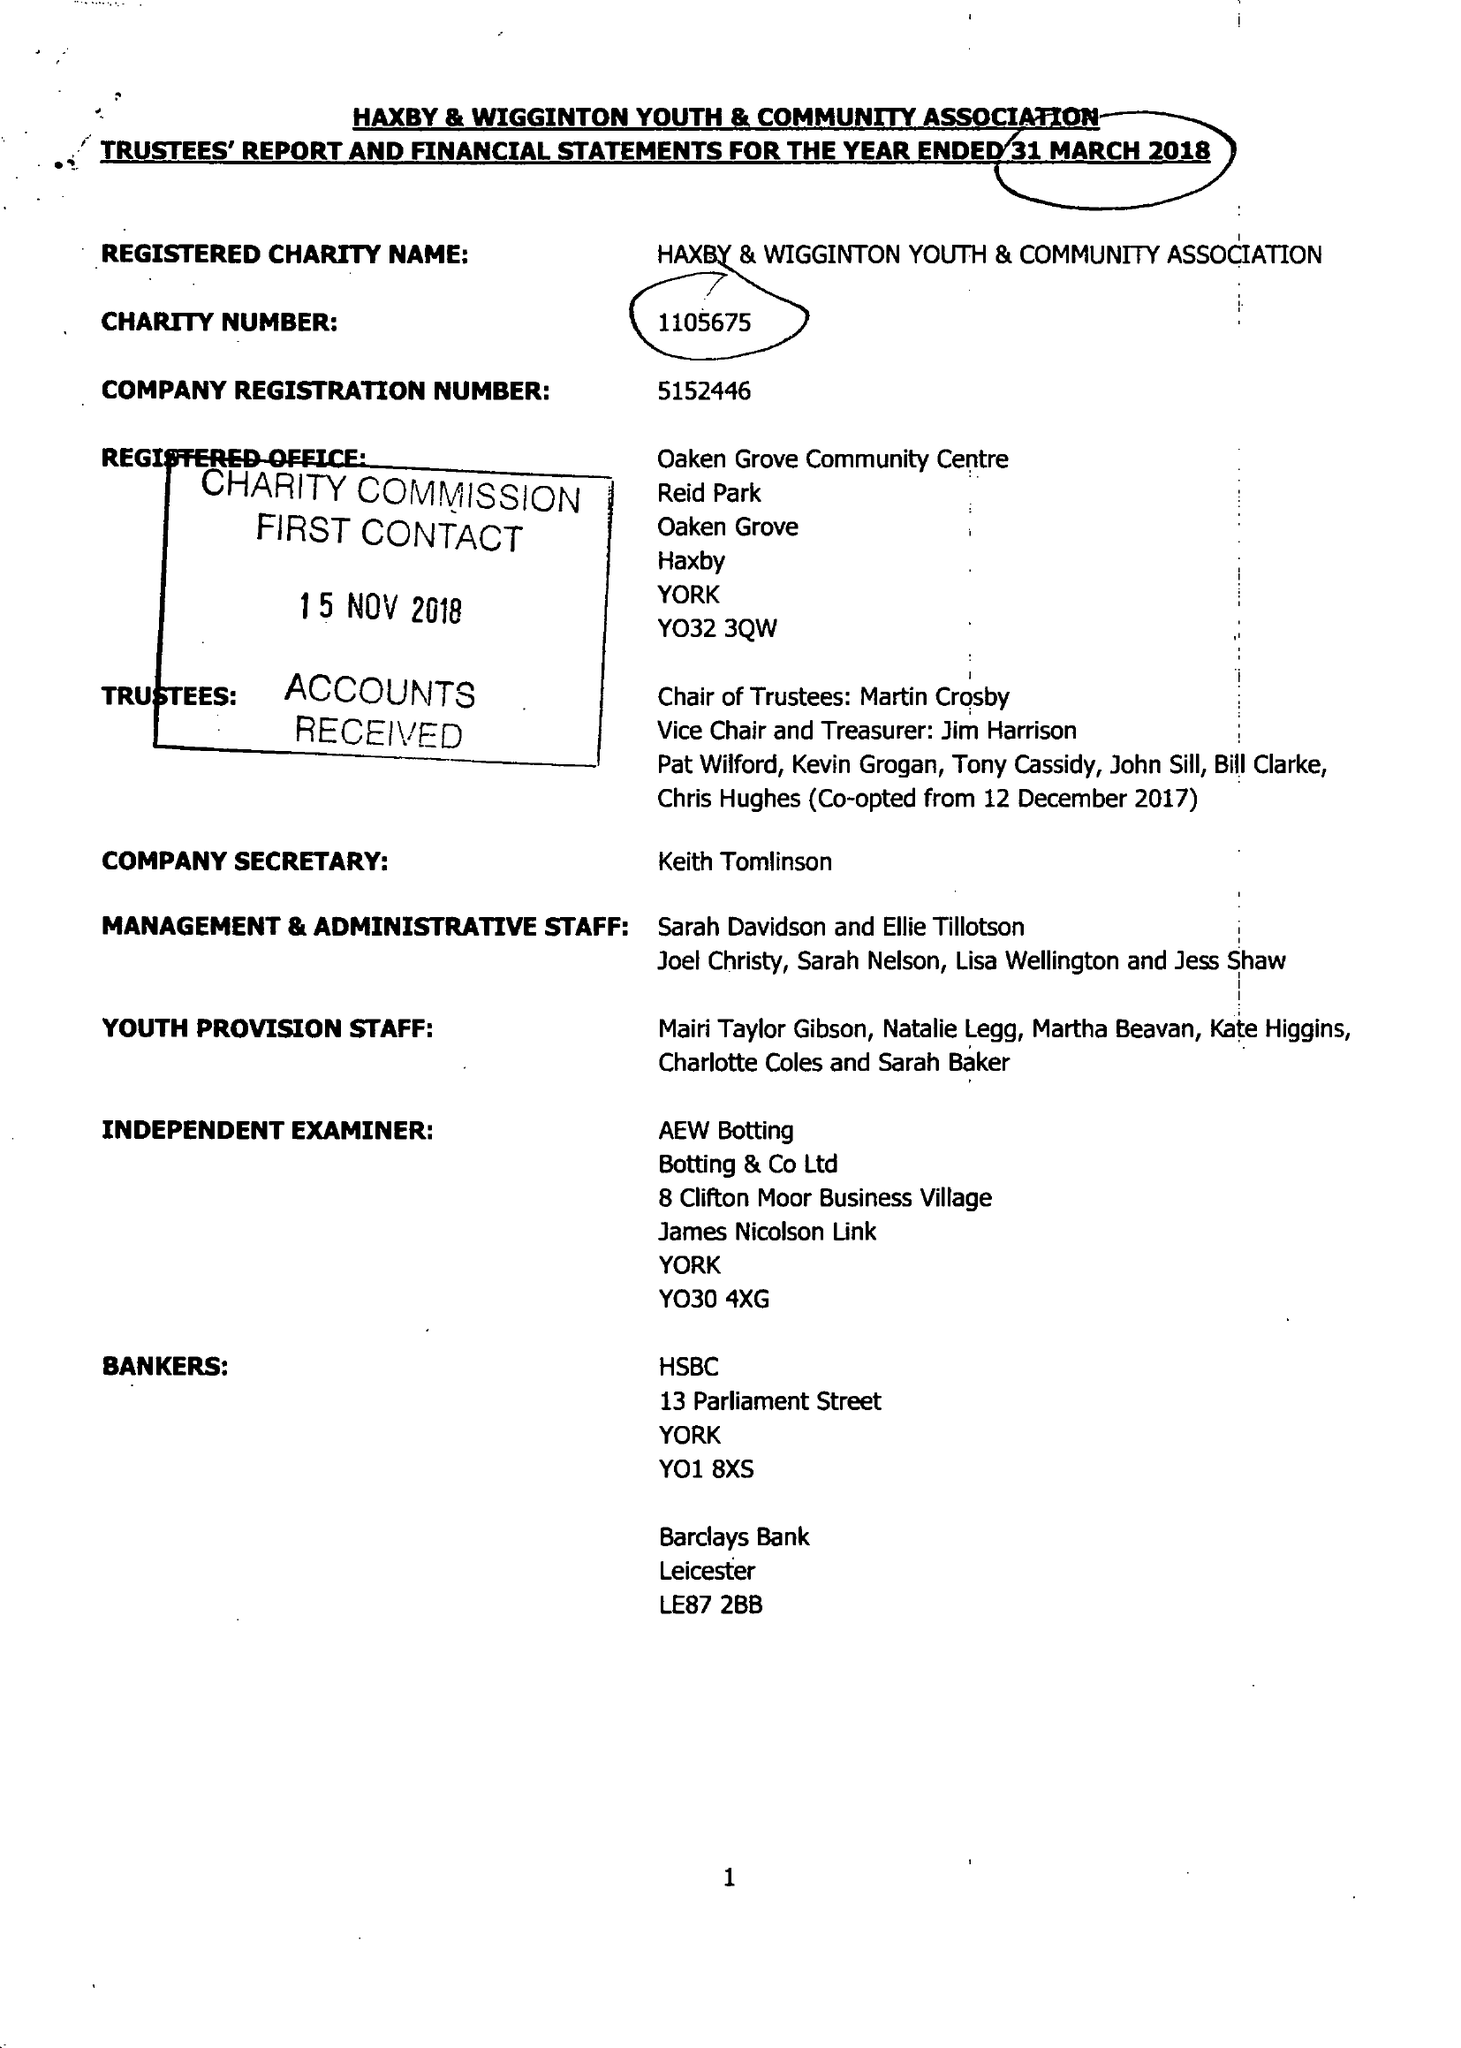What is the value for the address__postcode?
Answer the question using a single word or phrase. None 